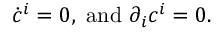<formula> <loc_0><loc_0><loc_500><loc_500>\dot { c } ^ { i } = 0 , a n d \partial _ { i } c ^ { i } = 0 .</formula> 